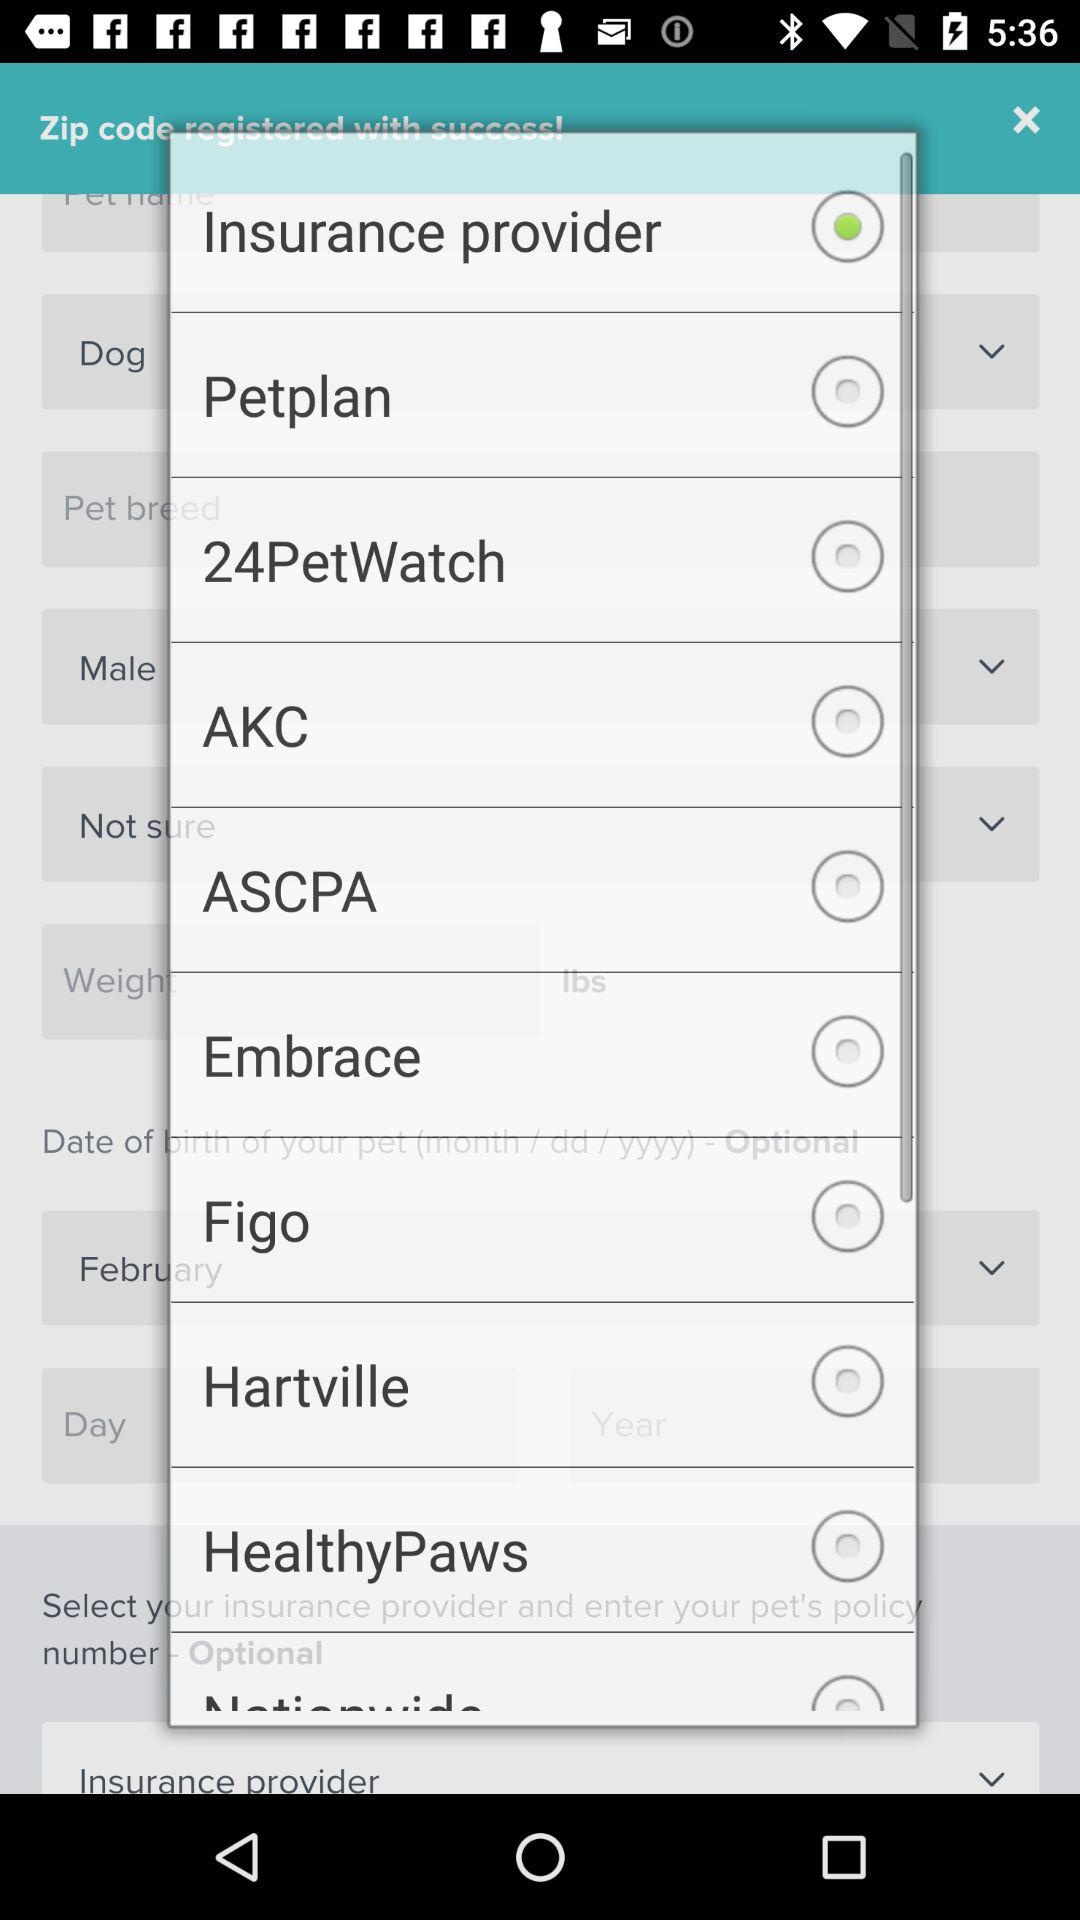How many insurance providers are there?
Answer the question using a single word or phrase. 8 